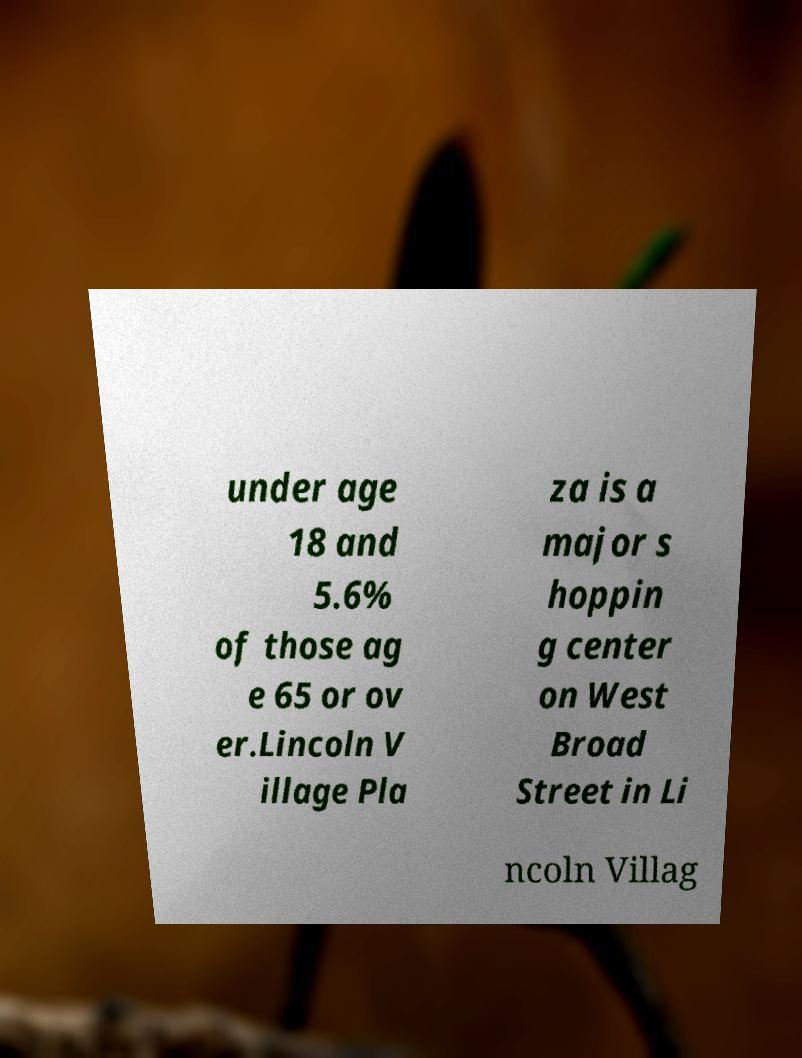There's text embedded in this image that I need extracted. Can you transcribe it verbatim? under age 18 and 5.6% of those ag e 65 or ov er.Lincoln V illage Pla za is a major s hoppin g center on West Broad Street in Li ncoln Villag 